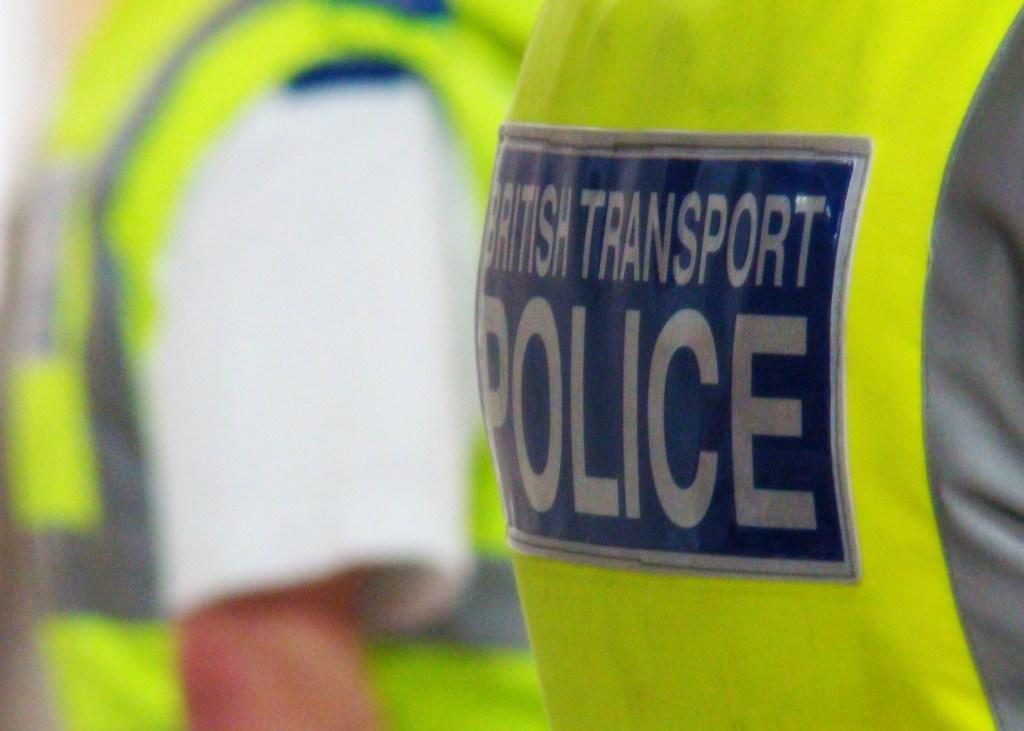<image>
Provide a brief description of the given image. the label on the back of the persons yellow vest says that they are part of the british transport police 